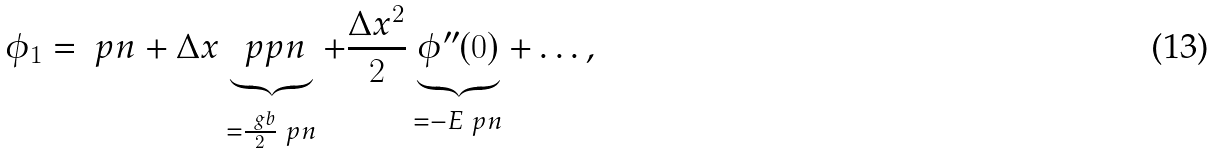<formula> <loc_0><loc_0><loc_500><loc_500>\phi _ { 1 } = \ p n + \Delta x \underbrace { \ p p n } _ { = \frac { \ g b } 2 \ p n } + \frac { \Delta x ^ { 2 } } 2 \underbrace { \phi ^ { \prime \prime } ( 0 ) } _ { = - E \ p n } + \dots ,</formula> 